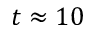Convert formula to latex. <formula><loc_0><loc_0><loc_500><loc_500>t \approx 1 0</formula> 